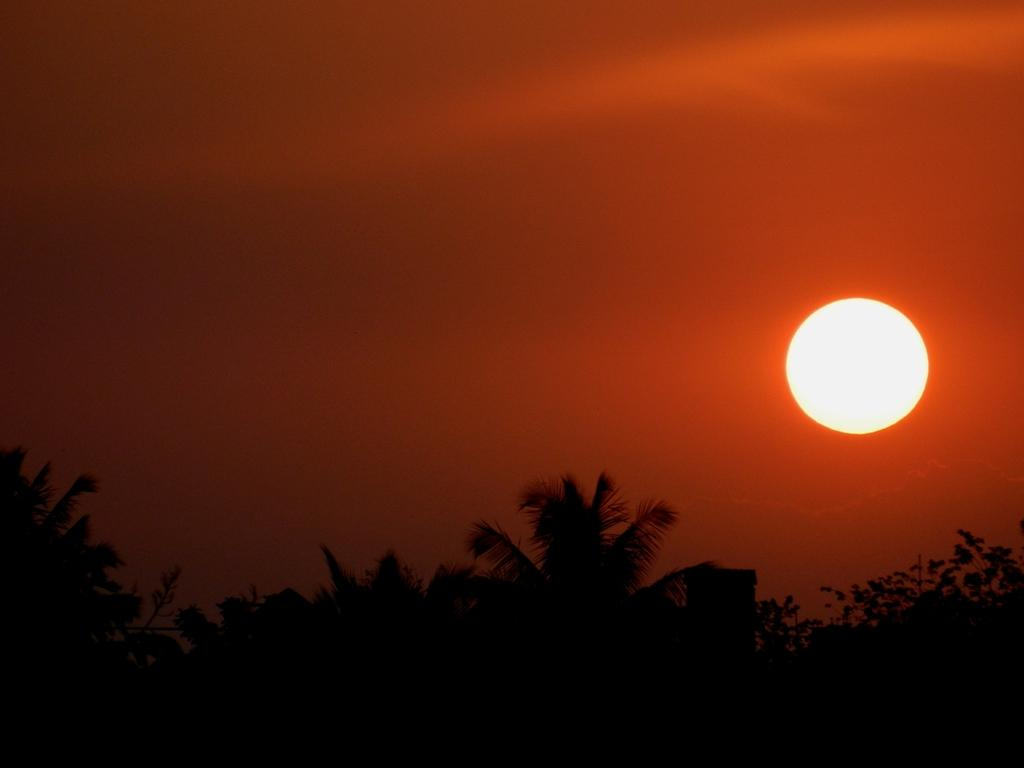What type of vegetation can be seen in the image? There are trees in the image. What celestial body is visible in the sky? The sun is visible in the sky. How does the bread increase in size in the image? There is no bread present in the image, so it cannot increase in size. 